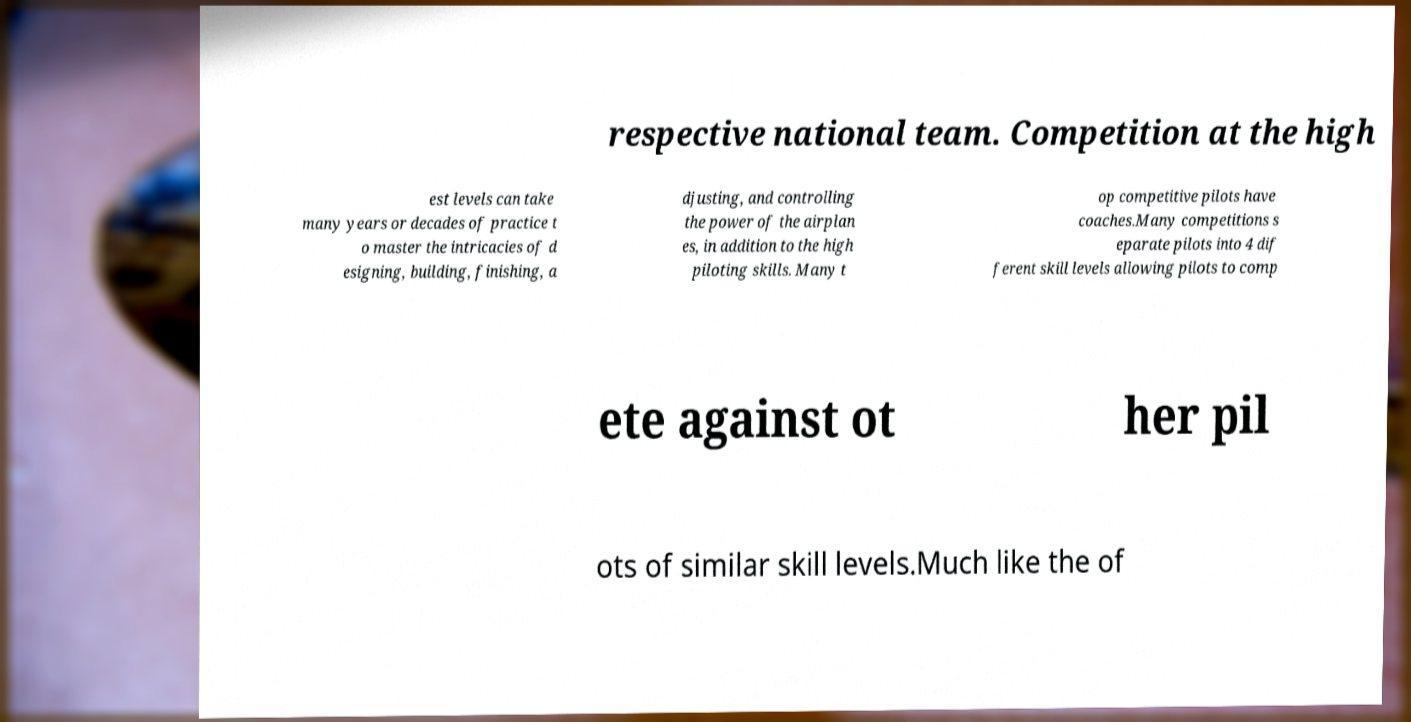For documentation purposes, I need the text within this image transcribed. Could you provide that? respective national team. Competition at the high est levels can take many years or decades of practice t o master the intricacies of d esigning, building, finishing, a djusting, and controlling the power of the airplan es, in addition to the high piloting skills. Many t op competitive pilots have coaches.Many competitions s eparate pilots into 4 dif ferent skill levels allowing pilots to comp ete against ot her pil ots of similar skill levels.Much like the of 